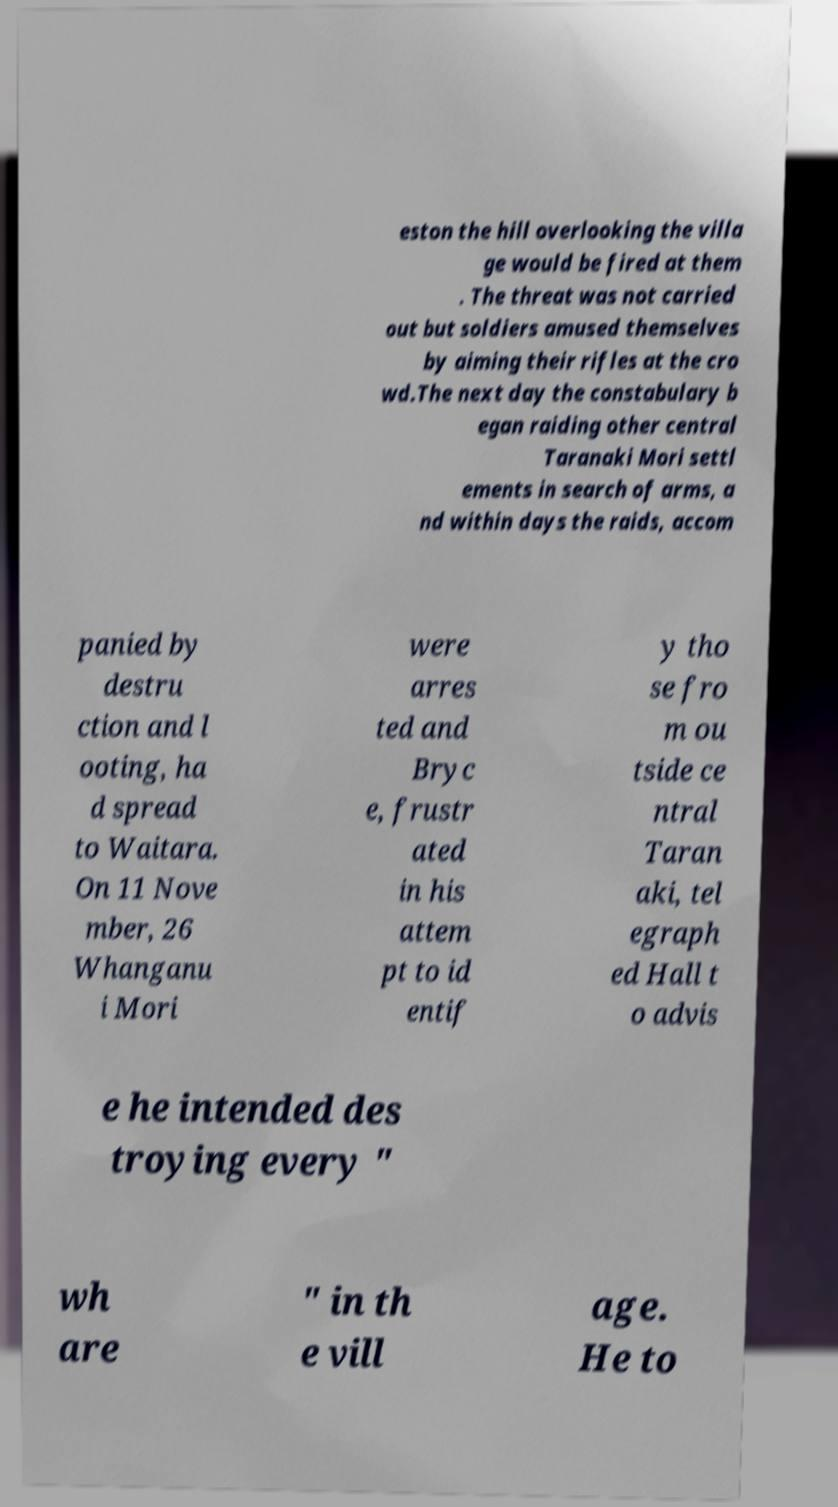There's text embedded in this image that I need extracted. Can you transcribe it verbatim? eston the hill overlooking the villa ge would be fired at them . The threat was not carried out but soldiers amused themselves by aiming their rifles at the cro wd.The next day the constabulary b egan raiding other central Taranaki Mori settl ements in search of arms, a nd within days the raids, accom panied by destru ction and l ooting, ha d spread to Waitara. On 11 Nove mber, 26 Whanganu i Mori were arres ted and Bryc e, frustr ated in his attem pt to id entif y tho se fro m ou tside ce ntral Taran aki, tel egraph ed Hall t o advis e he intended des troying every " wh are " in th e vill age. He to 